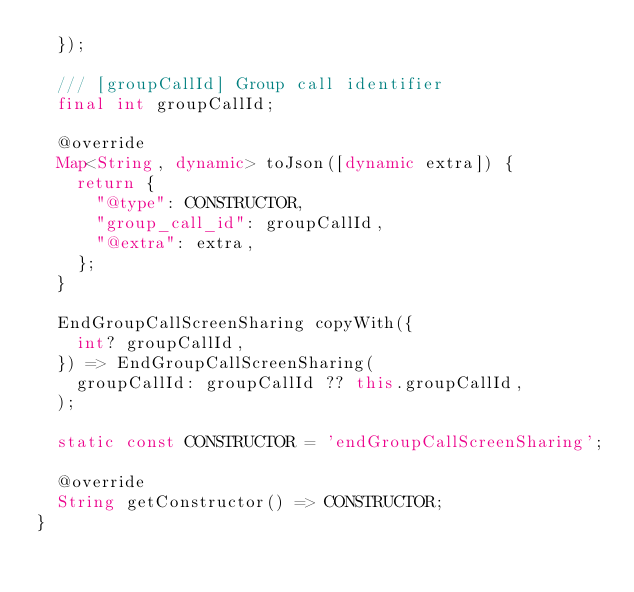<code> <loc_0><loc_0><loc_500><loc_500><_Dart_>  });
  
  /// [groupCallId] Group call identifier
  final int groupCallId;
  
  @override
  Map<String, dynamic> toJson([dynamic extra]) {
    return {
      "@type": CONSTRUCTOR,
      "group_call_id": groupCallId,
      "@extra": extra,
    };
  }
  
  EndGroupCallScreenSharing copyWith({
    int? groupCallId,
  }) => EndGroupCallScreenSharing(
    groupCallId: groupCallId ?? this.groupCallId,
  );

  static const CONSTRUCTOR = 'endGroupCallScreenSharing';
  
  @override
  String getConstructor() => CONSTRUCTOR;
}
</code> 